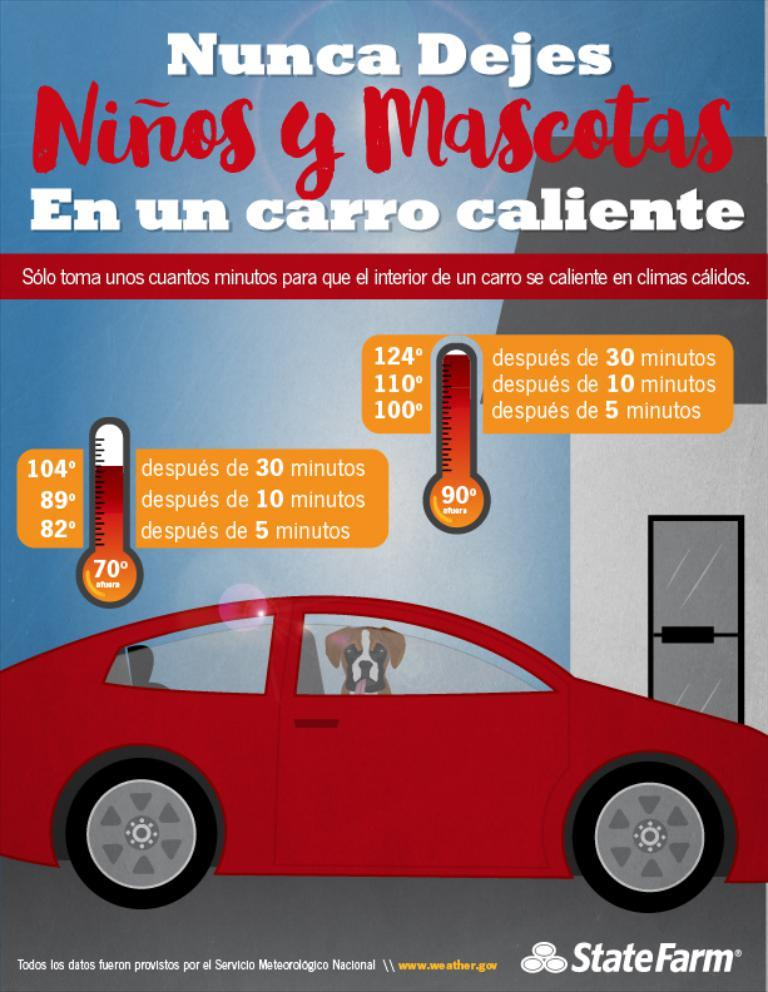What is depicted on the poster in the image? The poster features a dog inside a car. What else can be seen on the poster besides the dog and car? There is text on the poster. How many clocks are visible on the poster? There are no clocks visible on the poster; it features a dog inside a car and text. What type of country is depicted in the image? There is no country depicted in the image; it features a dog inside a car and text. 